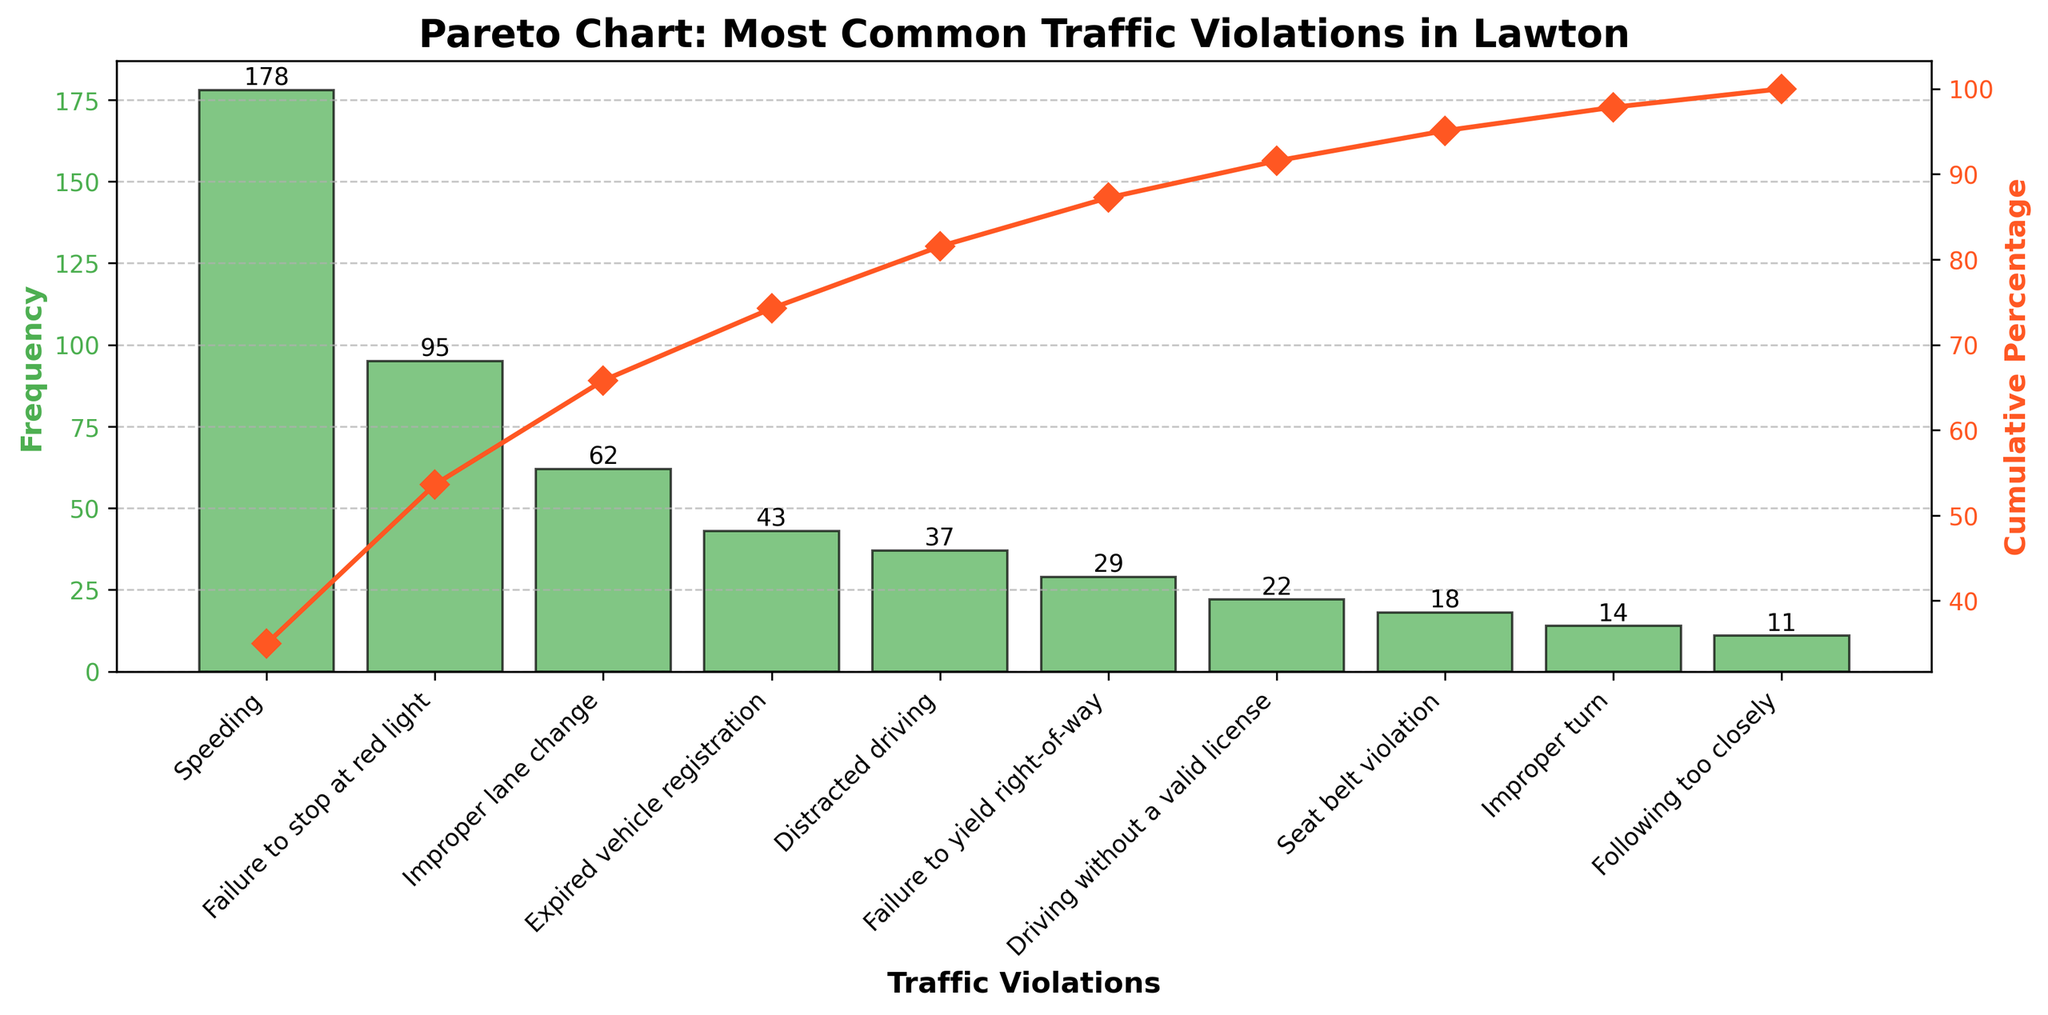What is the title of the chart? The title is located at the top of the chart, providing an overview of the figure's content.
Answer: Pareto Chart: Most Common Traffic Violations in Lawton What does the green color represent in the chart? The green color represents the frequency of each traffic violation shown as bars in the chart.
Answer: Frequency Which traffic violation has the highest frequency? The highest bar in the green section represents the traffic violation with the highest frequency, which is on the x-axis.
Answer: Speeding How many traffic violations are listed in the chart? Count all the distinct labels on the x-axis to determine the number of traffic violations represented in the chart.
Answer: 10 What is the cumulative percentage after the fourth most common traffic violation? The cumulative percentage can be found by looking at the orange line after the fourth x-axis label, which is "Expired vehicle registration".
Answer: 81.6% Which traffic violation contributes to more than 50% of total violations combined? The orange cumulative percentage line surpasses the 50% mark at the third traffic violation listed on the x-axis.
Answer: Speeding, Failure to stop at red light, Improper lane change What’s the combined frequency of "Expired vehicle registration" and "Distracted driving"? Add the frequencies of "Expired vehicle registration" (43) and "Distracted driving" (37) which are indicated by the heights of their respective bars.
Answer: 80 Compare the frequency of "Failure to yield right-of-way" and "Seat belt violation". Which one is higher and by how much? See the heights of the bars for both "Failure to yield right-of-way" (29) and "Seat belt violation" (18) and find the difference.
Answer: Failure to yield right-of-way by 11 What percentage of the total do "Driving without a valid license" and "Improper turn" contribute together? Sum the frequencies of both violations (22 and 14), then divide by the total frequency of all violations (509), and multiply by 100 to get the percentage.
Answer: 7.07% At which point does the cumulative percentage exceed 90%? Observe where the orange line crosses the 90% marker on the secondary y-axis and match it with the corresponding x-axis label.
Answer: Seat belt violation 